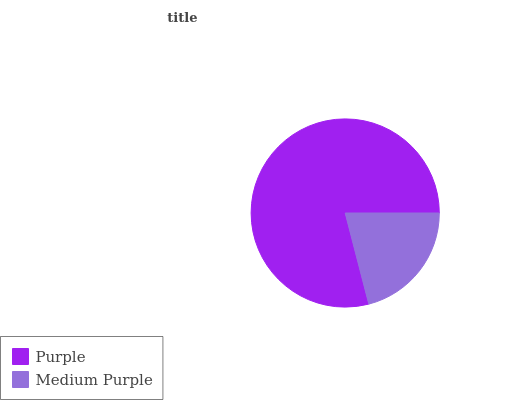Is Medium Purple the minimum?
Answer yes or no. Yes. Is Purple the maximum?
Answer yes or no. Yes. Is Medium Purple the maximum?
Answer yes or no. No. Is Purple greater than Medium Purple?
Answer yes or no. Yes. Is Medium Purple less than Purple?
Answer yes or no. Yes. Is Medium Purple greater than Purple?
Answer yes or no. No. Is Purple less than Medium Purple?
Answer yes or no. No. Is Purple the high median?
Answer yes or no. Yes. Is Medium Purple the low median?
Answer yes or no. Yes. Is Medium Purple the high median?
Answer yes or no. No. Is Purple the low median?
Answer yes or no. No. 